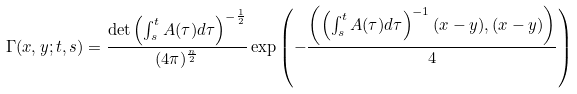<formula> <loc_0><loc_0><loc_500><loc_500>\Gamma ( x , y ; t , s ) = \frac { \det \left ( \int _ { s } ^ { t } A ( \tau ) d \tau \right ) ^ { - \frac { 1 } { 2 } } } { ( 4 \pi ) ^ { \frac { n } { 2 } } } \exp \left ( - \frac { \left ( \left ( \int _ { s } ^ { t } A ( \tau ) d \tau \right ) ^ { - 1 } ( x - y ) , ( x - y ) \right ) } 4 \right )</formula> 